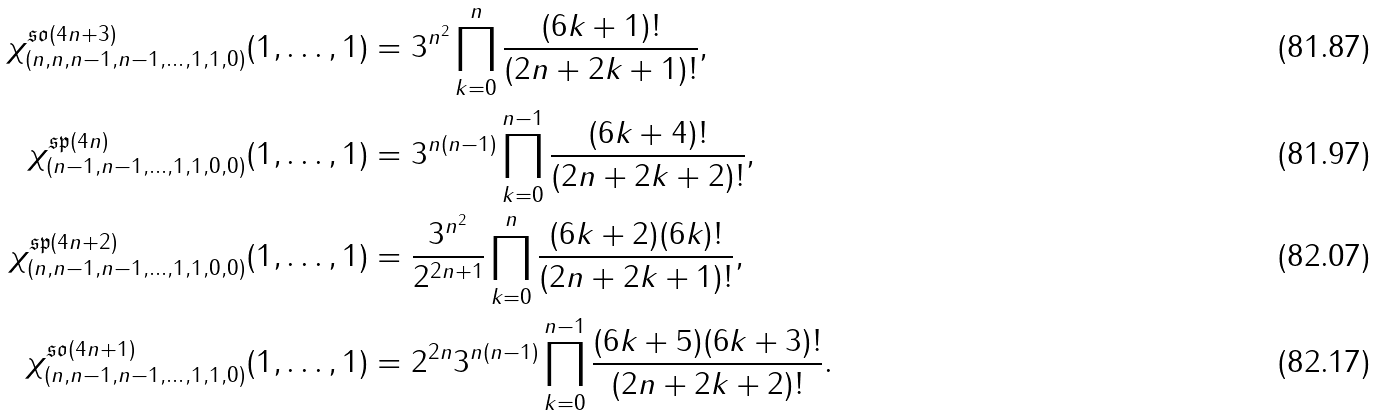<formula> <loc_0><loc_0><loc_500><loc_500>\chi _ { ( n , n , n - 1 , n - 1 , \dots , 1 , 1 , 0 ) } ^ { \mathfrak { s o } ( 4 n + 3 ) } ( 1 , \dots , 1 ) & = 3 ^ { n ^ { 2 } } \prod _ { k = 0 } ^ { n } \frac { ( 6 k + 1 ) ! } { ( 2 n + 2 k + 1 ) ! } , \\ \chi _ { ( n - 1 , n - 1 , \dots , 1 , 1 , 0 , 0 ) } ^ { \mathfrak { s p } ( 4 n ) } ( 1 , \dots , 1 ) & = 3 ^ { n ( n - 1 ) } \prod _ { k = 0 } ^ { n - 1 } \frac { ( 6 k + 4 ) ! } { ( 2 n + 2 k + 2 ) ! } , \\ \chi _ { ( n , n - 1 , n - 1 , \dots , 1 , 1 , 0 , 0 ) } ^ { \mathfrak { s p } ( 4 n + 2 ) } ( 1 , \dots , 1 ) & = \frac { 3 ^ { n ^ { 2 } } } { 2 ^ { 2 n + 1 } } \prod _ { k = 0 } ^ { n } \frac { ( 6 k + 2 ) ( 6 k ) ! } { ( 2 n + 2 k + 1 ) ! } , \\ \chi _ { ( n , n - 1 , n - 1 , \dots , 1 , 1 , 0 ) } ^ { \mathfrak { s o } ( 4 n + 1 ) } ( 1 , \dots , 1 ) & = { 2 ^ { 2 n } 3 ^ { n ( n - 1 ) } } \prod _ { k = 0 } ^ { n - 1 } \frac { ( 6 k + 5 ) ( 6 k + 3 ) ! } { ( 2 n + 2 k + 2 ) ! } .</formula> 